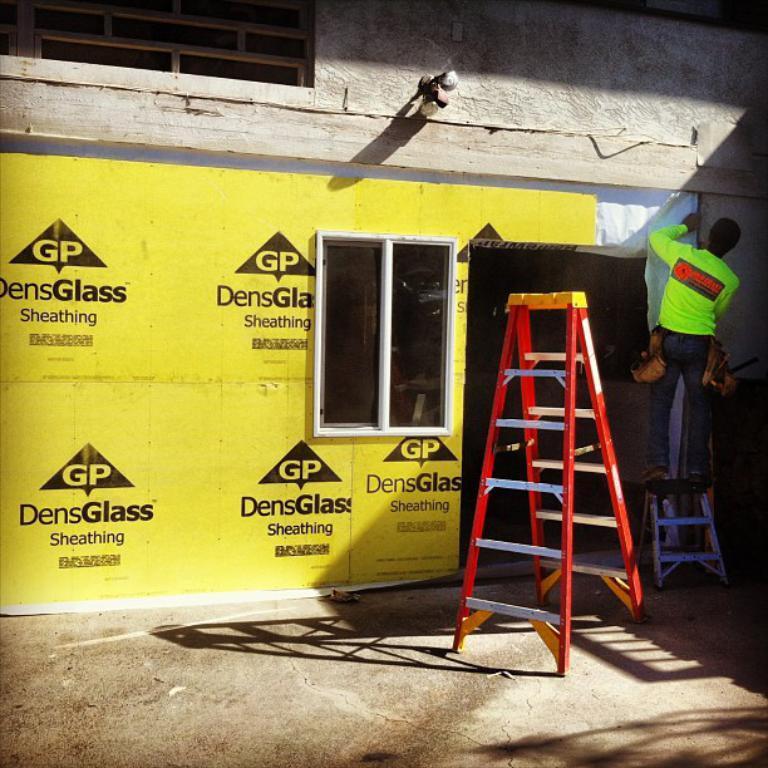Describe this image in one or two sentences. On the right side a person is standing on a ladder. Near to him there is another ladder. In the back there's a wall. On that some poster is pasted. Also there is a window. 